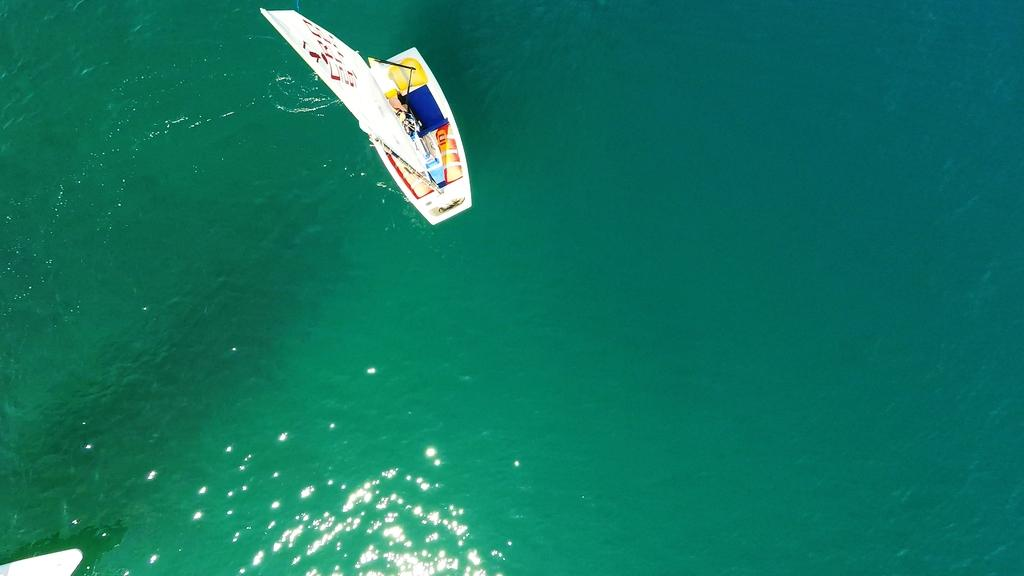What type of boat is in the image? There is a cat boat in the image. Where is the cat boat located? The cat boat is on the water. What can be seen inside the boat? There are objects placed in the boat. How does the image indicate the direction of the wind? The image shows the direction according to the wind. What type of pie is being served on the wall in the image? There is no pie or wall present in the image; it features a cat boat on the water. 